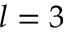<formula> <loc_0><loc_0><loc_500><loc_500>l = 3</formula> 